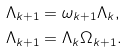<formula> <loc_0><loc_0><loc_500><loc_500>\Lambda _ { k + 1 } & = \omega _ { k + 1 } \Lambda _ { k } , \\ \Lambda _ { k + 1 } & = \Lambda _ { k } \Omega _ { k + 1 } . \\</formula> 